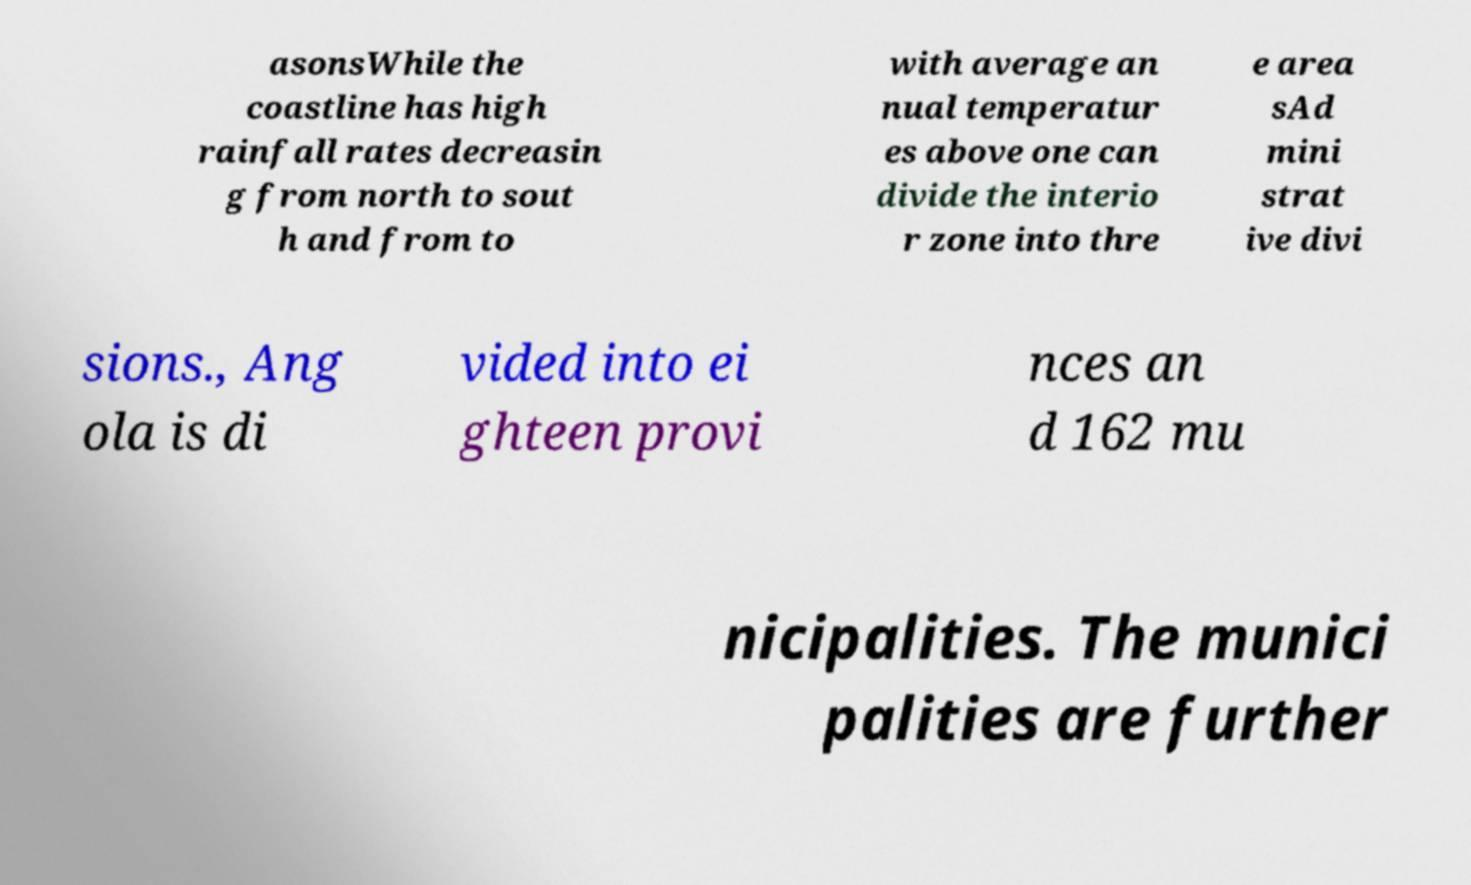Can you read and provide the text displayed in the image?This photo seems to have some interesting text. Can you extract and type it out for me? asonsWhile the coastline has high rainfall rates decreasin g from north to sout h and from to with average an nual temperatur es above one can divide the interio r zone into thre e area sAd mini strat ive divi sions., Ang ola is di vided into ei ghteen provi nces an d 162 mu nicipalities. The munici palities are further 